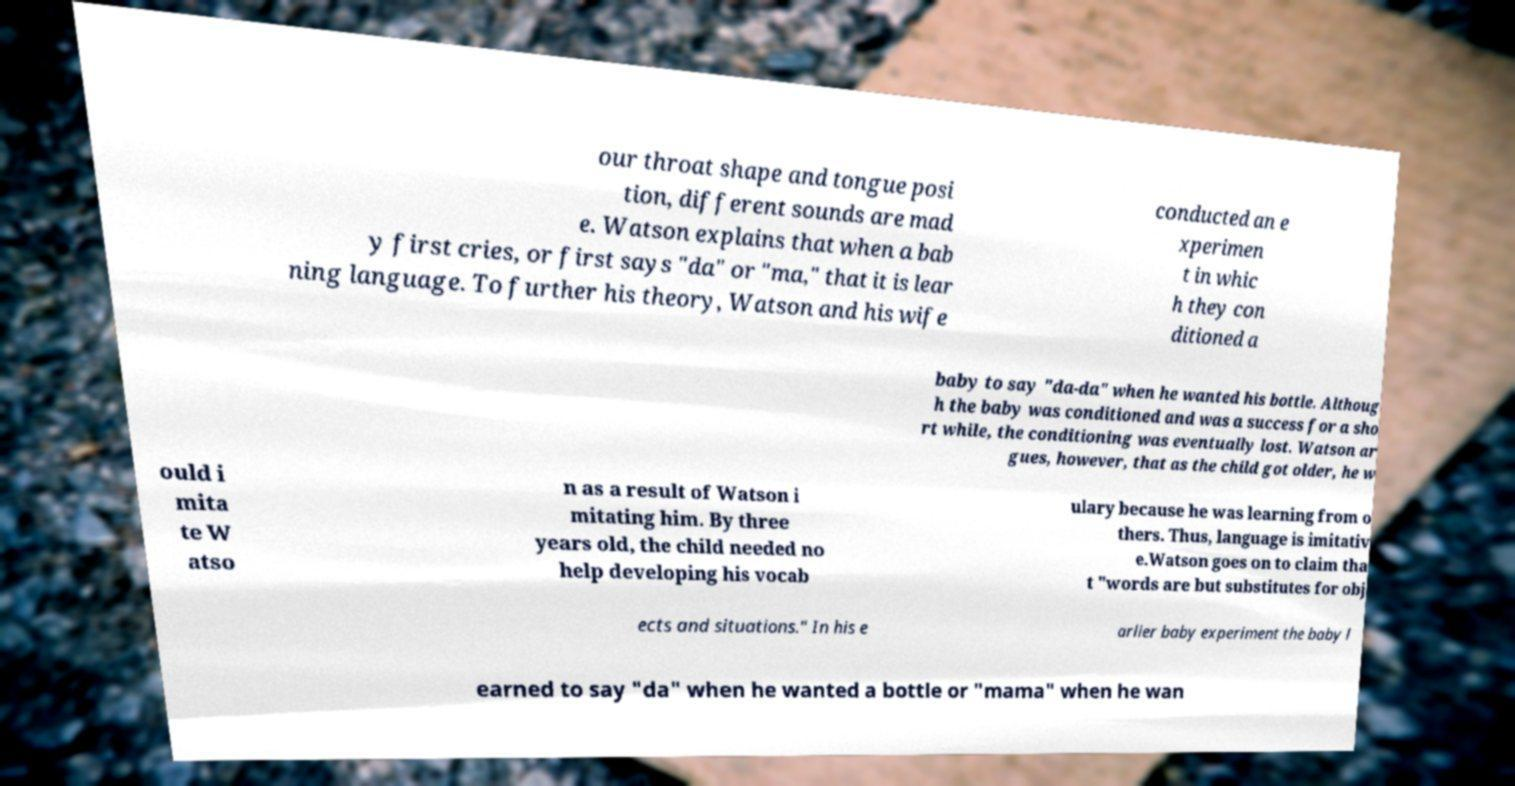There's text embedded in this image that I need extracted. Can you transcribe it verbatim? our throat shape and tongue posi tion, different sounds are mad e. Watson explains that when a bab y first cries, or first says "da" or "ma," that it is lear ning language. To further his theory, Watson and his wife conducted an e xperimen t in whic h they con ditioned a baby to say "da-da" when he wanted his bottle. Althoug h the baby was conditioned and was a success for a sho rt while, the conditioning was eventually lost. Watson ar gues, however, that as the child got older, he w ould i mita te W atso n as a result of Watson i mitating him. By three years old, the child needed no help developing his vocab ulary because he was learning from o thers. Thus, language is imitativ e.Watson goes on to claim tha t "words are but substitutes for obj ects and situations." In his e arlier baby experiment the baby l earned to say "da" when he wanted a bottle or "mama" when he wan 